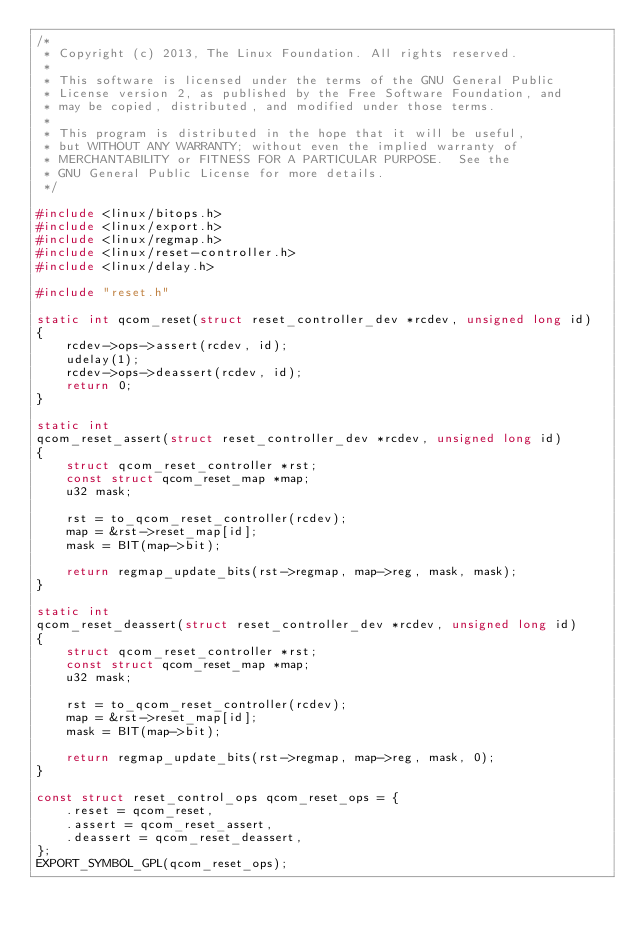Convert code to text. <code><loc_0><loc_0><loc_500><loc_500><_C_>/*
 * Copyright (c) 2013, The Linux Foundation. All rights reserved.
 *
 * This software is licensed under the terms of the GNU General Public
 * License version 2, as published by the Free Software Foundation, and
 * may be copied, distributed, and modified under those terms.
 *
 * This program is distributed in the hope that it will be useful,
 * but WITHOUT ANY WARRANTY; without even the implied warranty of
 * MERCHANTABILITY or FITNESS FOR A PARTICULAR PURPOSE.  See the
 * GNU General Public License for more details.
 */

#include <linux/bitops.h>
#include <linux/export.h>
#include <linux/regmap.h>
#include <linux/reset-controller.h>
#include <linux/delay.h>

#include "reset.h"

static int qcom_reset(struct reset_controller_dev *rcdev, unsigned long id)
{
	rcdev->ops->assert(rcdev, id);
	udelay(1);
	rcdev->ops->deassert(rcdev, id);
	return 0;
}

static int
qcom_reset_assert(struct reset_controller_dev *rcdev, unsigned long id)
{
	struct qcom_reset_controller *rst;
	const struct qcom_reset_map *map;
	u32 mask;

	rst = to_qcom_reset_controller(rcdev);
	map = &rst->reset_map[id];
	mask = BIT(map->bit);

	return regmap_update_bits(rst->regmap, map->reg, mask, mask);
}

static int
qcom_reset_deassert(struct reset_controller_dev *rcdev, unsigned long id)
{
	struct qcom_reset_controller *rst;
	const struct qcom_reset_map *map;
	u32 mask;

	rst = to_qcom_reset_controller(rcdev);
	map = &rst->reset_map[id];
	mask = BIT(map->bit);

	return regmap_update_bits(rst->regmap, map->reg, mask, 0);
}

const struct reset_control_ops qcom_reset_ops = {
	.reset = qcom_reset,
	.assert = qcom_reset_assert,
	.deassert = qcom_reset_deassert,
};
EXPORT_SYMBOL_GPL(qcom_reset_ops);
</code> 